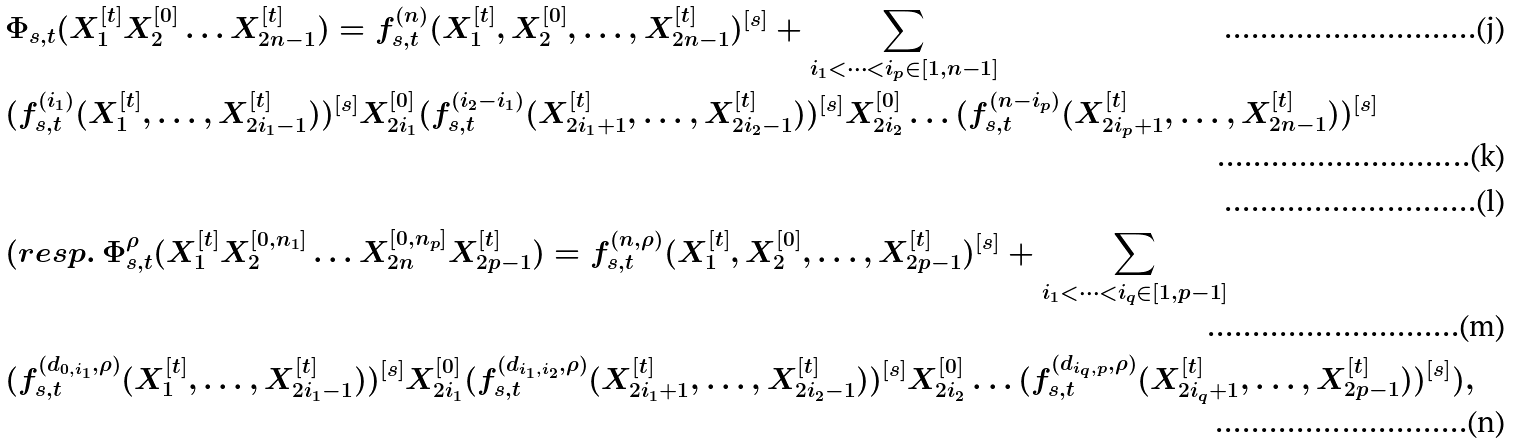<formula> <loc_0><loc_0><loc_500><loc_500>& \Phi _ { s , t } ( X _ { 1 } ^ { [ t ] } X _ { 2 } ^ { [ 0 ] } \dots X _ { 2 n - 1 } ^ { [ t ] } ) = f _ { s , t } ^ { ( n ) } ( X _ { 1 } ^ { [ t ] } , X _ { 2 } ^ { [ 0 ] } , \dots , X _ { 2 n - 1 } ^ { [ t ] } ) ^ { [ s ] } + \sum _ { i _ { 1 } < \dots < i _ { p } \in [ 1 , n - 1 ] } \\ & ( f _ { s , t } ^ { ( i _ { 1 } ) } ( X _ { 1 } ^ { [ t ] } , \dots , X _ { 2 i _ { 1 } - 1 } ^ { [ t ] } ) ) ^ { [ s ] } X _ { 2 i _ { 1 } } ^ { [ 0 ] } ( f _ { s , t } ^ { ( i _ { 2 } - i _ { 1 } ) } ( X _ { 2 i _ { 1 } + 1 } ^ { [ t ] } , \dots , X _ { 2 i _ { 2 } - 1 } ^ { [ t ] } ) ) ^ { [ s ] } X _ { 2 i _ { 2 } } ^ { [ 0 ] } \dots ( f _ { s , t } ^ { ( n - i _ { p } ) } ( X _ { 2 i _ { p } + 1 } ^ { [ t ] } , \dots , X _ { 2 n - 1 } ^ { [ t ] } ) ) ^ { [ s ] } \\ & \\ & ( r e s p . \ \Phi _ { s , t } ^ { \rho } ( X _ { 1 } ^ { [ t ] } X _ { 2 } ^ { [ 0 , n _ { 1 } ] } \dots X _ { 2 n } ^ { [ 0 , n _ { p } ] } X _ { 2 p - 1 } ^ { [ t ] } ) = f _ { s , t } ^ { ( n , \rho ) } ( X _ { 1 } ^ { [ t ] } , X _ { 2 } ^ { [ 0 ] } , \dots , X _ { 2 p - 1 } ^ { [ t ] } ) ^ { [ s ] } + \sum _ { i _ { 1 } < \dots < i _ { q } \in [ 1 , p - 1 ] } \\ & ( f _ { s , t } ^ { ( d _ { 0 , i _ { 1 } } , \rho ) } ( X _ { 1 } ^ { [ t ] } , \dots , X _ { 2 i _ { 1 } - 1 } ^ { [ t ] } ) ) ^ { [ s ] } X _ { 2 i _ { 1 } } ^ { [ 0 ] } ( f _ { s , t } ^ { ( d _ { i _ { 1 } , i _ { 2 } } , \rho ) } ( X _ { 2 i _ { 1 } + 1 } ^ { [ t ] } , \dots , X _ { 2 i _ { 2 } - 1 } ^ { [ t ] } ) ) ^ { [ s ] } X _ { 2 i _ { 2 } } ^ { [ 0 ] } \dots ( f _ { s , t } ^ { ( d _ { i _ { q } , p } , \rho ) } ( X _ { 2 i _ { q } + 1 } ^ { [ t ] } , \dots , X _ { 2 p - 1 } ^ { [ t ] } ) ) ^ { [ s ] } ) ,</formula> 